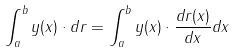Convert formula to latex. <formula><loc_0><loc_0><loc_500><loc_500>\int _ { a } ^ { b } y ( x ) \cdot d r = \int _ { a } ^ { b } y ( x ) \cdot { \frac { d r ( x ) } { d x } } d x</formula> 